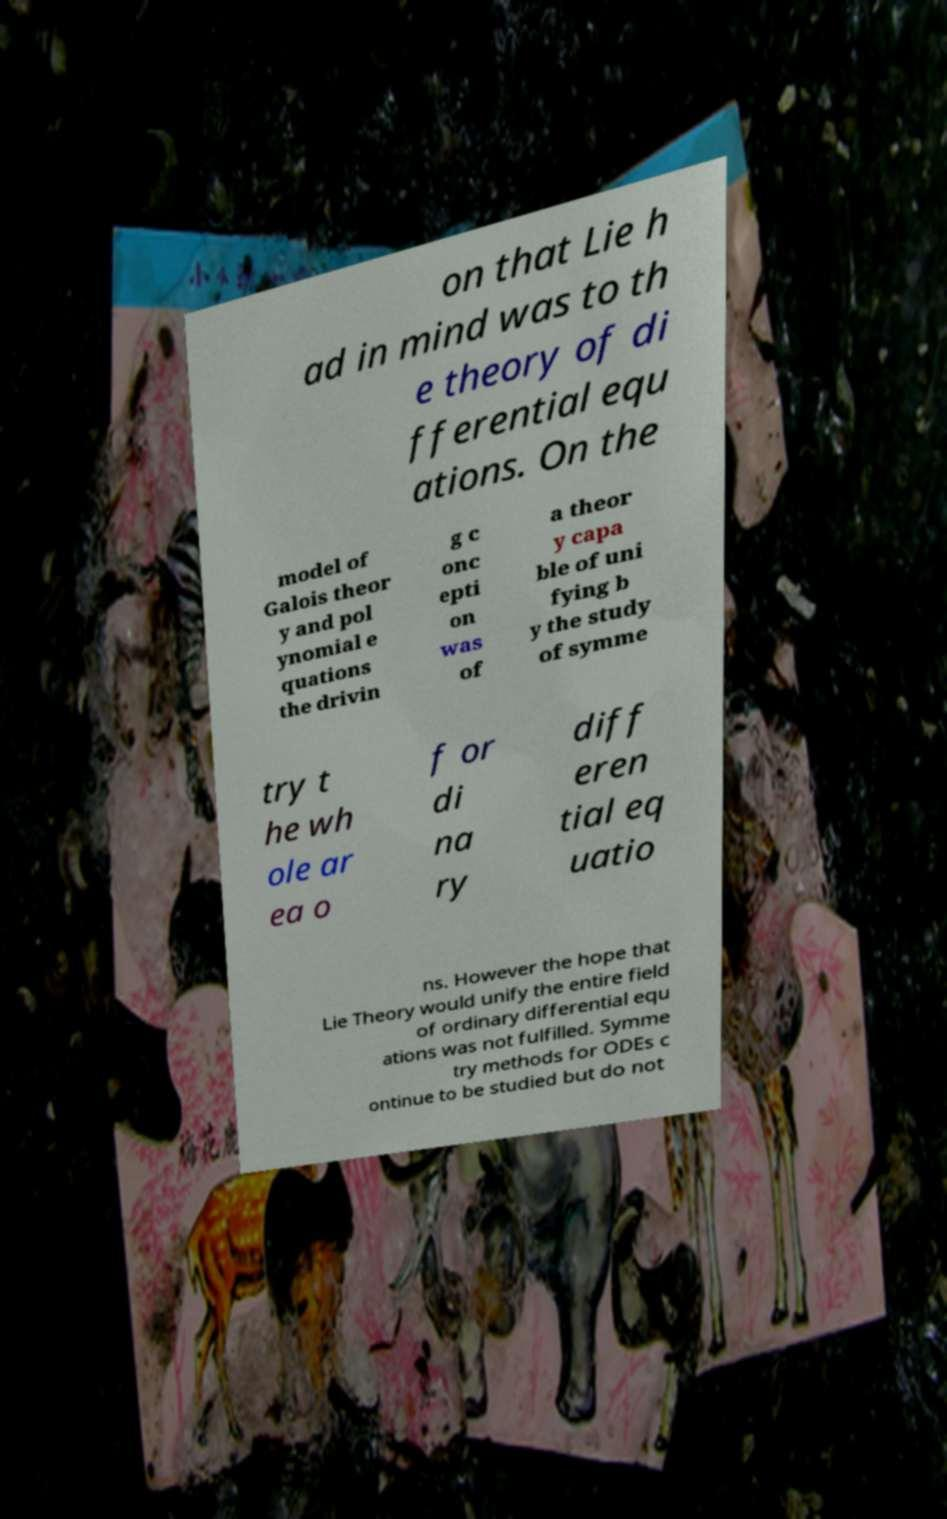Please identify and transcribe the text found in this image. on that Lie h ad in mind was to th e theory of di fferential equ ations. On the model of Galois theor y and pol ynomial e quations the drivin g c onc epti on was of a theor y capa ble of uni fying b y the study of symme try t he wh ole ar ea o f or di na ry diff eren tial eq uatio ns. However the hope that Lie Theory would unify the entire field of ordinary differential equ ations was not fulfilled. Symme try methods for ODEs c ontinue to be studied but do not 